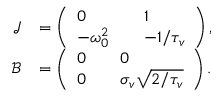Convert formula to latex. <formula><loc_0><loc_0><loc_500><loc_500>\begin{array} { r l } { \mathcal { J } } & { = \left ( \begin{array} { l l l } { 0 } & & { 1 } \\ { - \omega _ { 0 } ^ { 2 } } & & { - 1 / { \tau _ { v } } } \end{array} \right ) , } \\ { \mathcal { B } } & { = \left ( \begin{array} { l l l } { 0 } & & { 0 } \\ { 0 } & & { \sigma _ { v } \sqrt { 2 / \tau _ { v } } } \end{array} \right ) . } \end{array}</formula> 